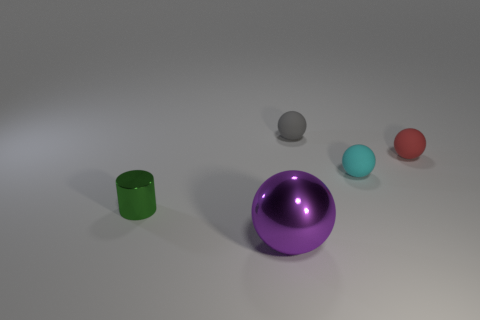Subtract all gray rubber balls. How many balls are left? 3 Add 2 tiny matte balls. How many objects exist? 7 Subtract all gray balls. How many balls are left? 3 Subtract all cyan spheres. Subtract all red blocks. How many spheres are left? 3 Subtract 0 purple cubes. How many objects are left? 5 Subtract all cylinders. How many objects are left? 4 Subtract all green things. Subtract all large purple cylinders. How many objects are left? 4 Add 4 purple things. How many purple things are left? 5 Add 1 metal cylinders. How many metal cylinders exist? 2 